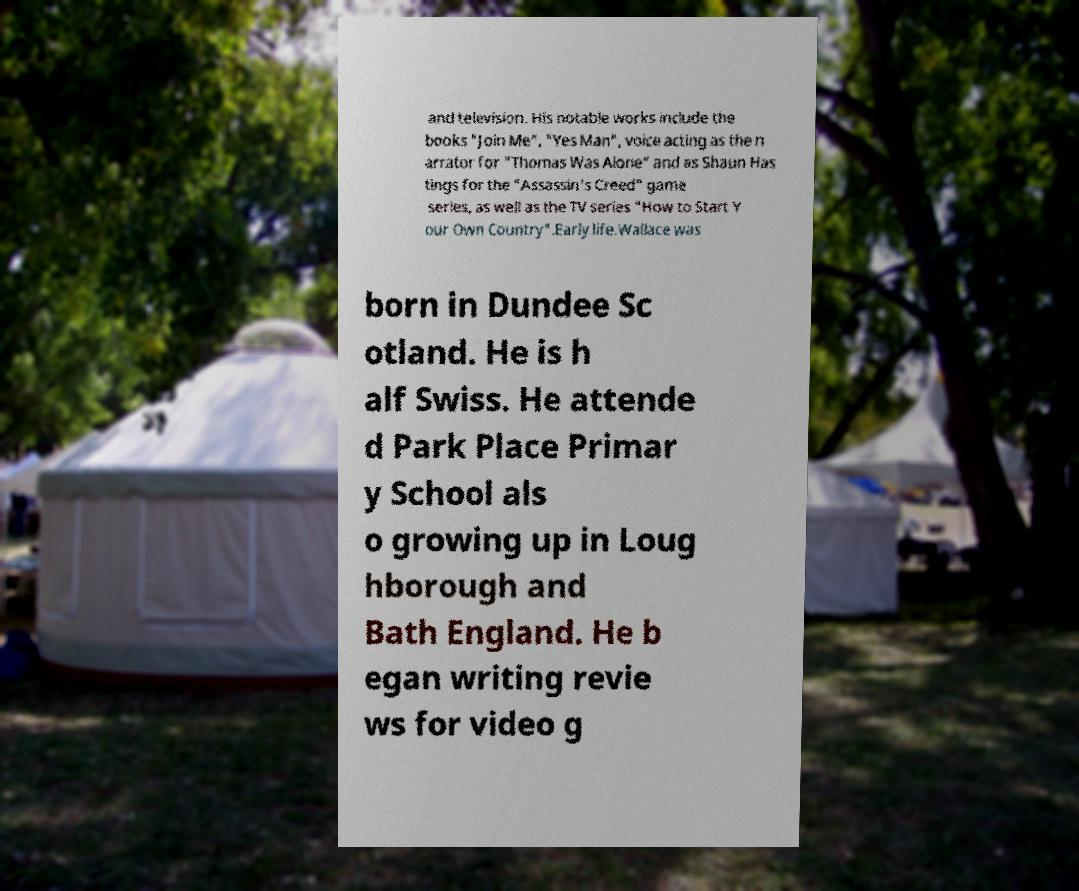There's text embedded in this image that I need extracted. Can you transcribe it verbatim? and television. His notable works include the books "Join Me", "Yes Man", voice acting as the n arrator for "Thomas Was Alone" and as Shaun Has tings for the "Assassin's Creed" game series, as well as the TV series "How to Start Y our Own Country".Early life.Wallace was born in Dundee Sc otland. He is h alf Swiss. He attende d Park Place Primar y School als o growing up in Loug hborough and Bath England. He b egan writing revie ws for video g 